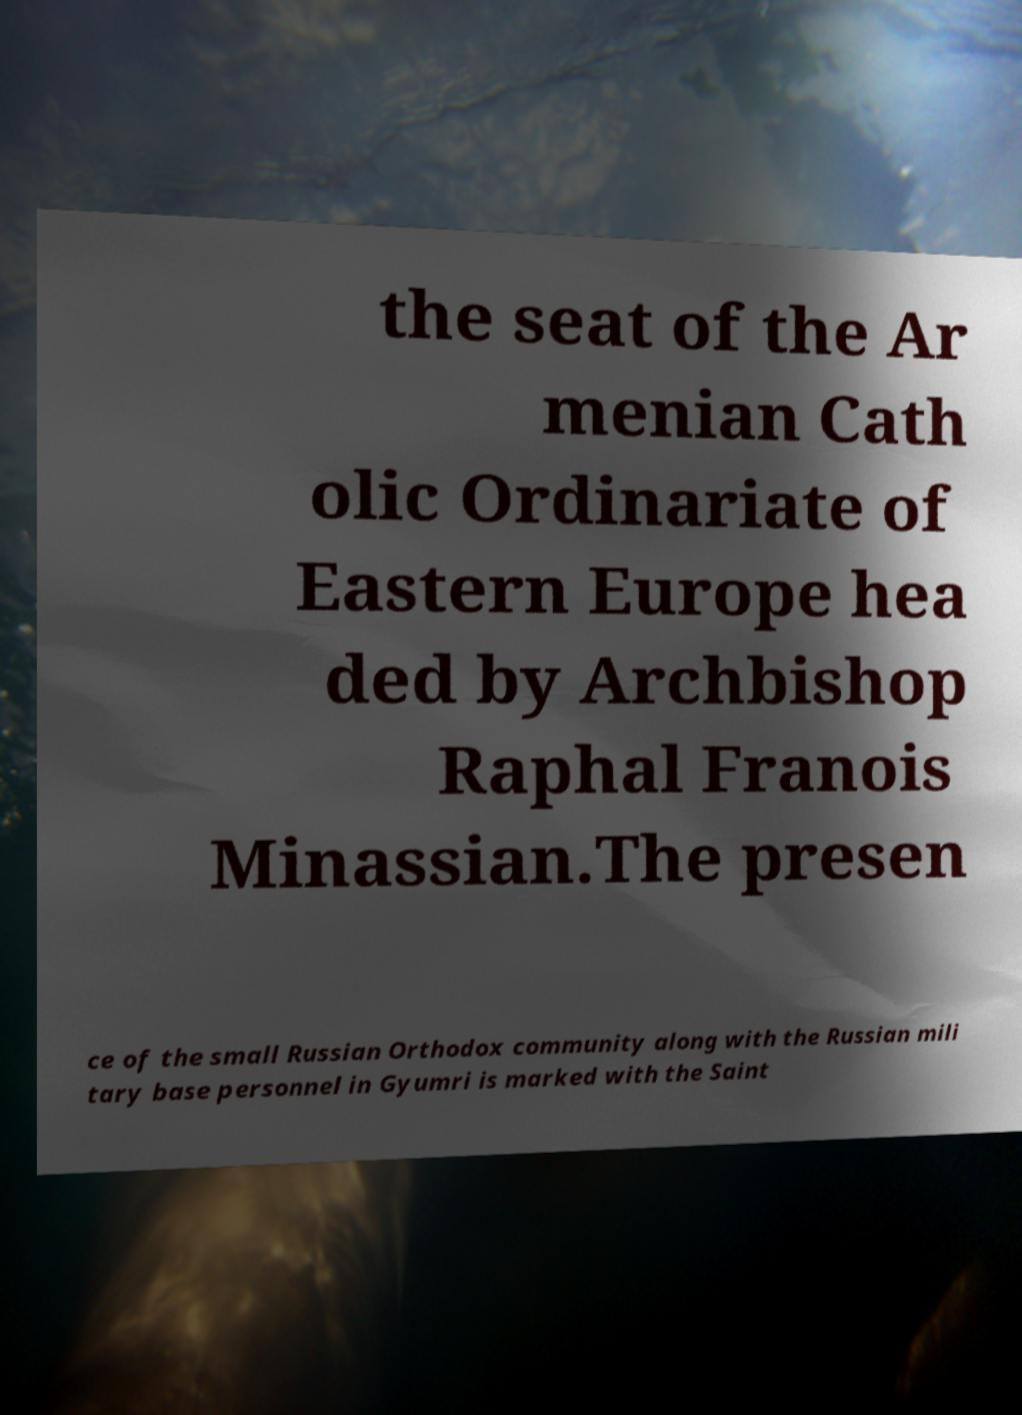Could you assist in decoding the text presented in this image and type it out clearly? the seat of the Ar menian Cath olic Ordinariate of Eastern Europe hea ded by Archbishop Raphal Franois Minassian.The presen ce of the small Russian Orthodox community along with the Russian mili tary base personnel in Gyumri is marked with the Saint 